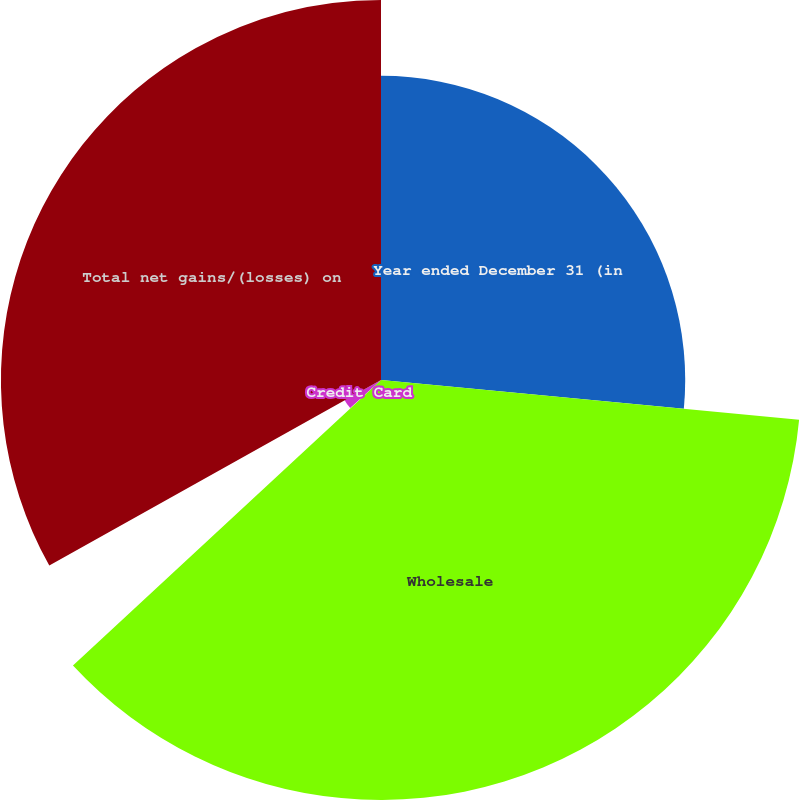Convert chart to OTSL. <chart><loc_0><loc_0><loc_500><loc_500><pie_chart><fcel>Year ended December 31 (in<fcel>Wholesale<fcel>Consumer excluding credit card<fcel>Credit Card<fcel>Total net gains/(losses) on<nl><fcel>26.51%<fcel>36.6%<fcel>0.15%<fcel>3.63%<fcel>33.12%<nl></chart> 